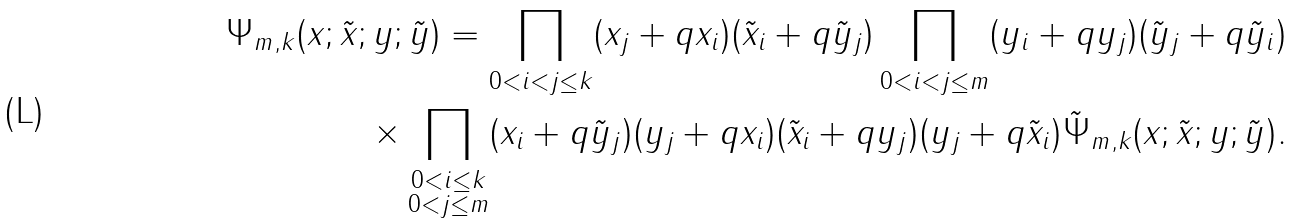<formula> <loc_0><loc_0><loc_500><loc_500>\Psi _ { m , k } ( x ; \tilde { x } ; y ; \tilde { y } ) = \prod _ { 0 < i < j \leq k } ( x _ { j } + q x _ { i } ) ( \tilde { x } _ { i } + q \tilde { y } _ { j } ) \prod _ { 0 < i < j \leq m } ( y _ { i } + q y _ { j } ) ( \tilde { y } _ { j } + q \tilde { y } _ { i } ) \\ \times \prod _ { \substack { 0 < i \leq k \\ 0 < j \leq m } } ( x _ { i } + q \tilde { y } _ { j } ) ( y _ { j } + q x _ { i } ) ( \tilde { x } _ { i } + q y _ { j } ) ( y _ { j } + q \tilde { x } _ { i } ) \tilde { \Psi } _ { m , k } ( x ; \tilde { x } ; y ; \tilde { y } ) .</formula> 